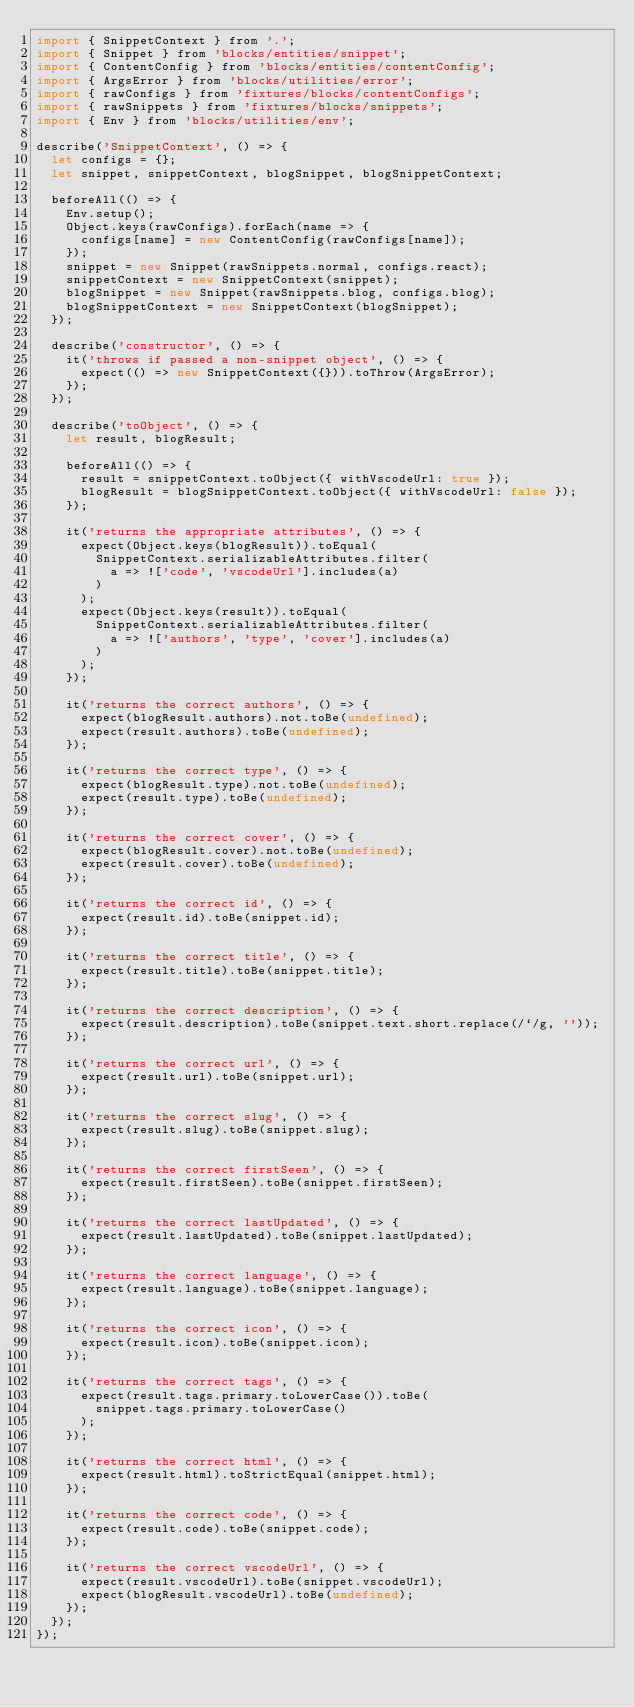Convert code to text. <code><loc_0><loc_0><loc_500><loc_500><_JavaScript_>import { SnippetContext } from '.';
import { Snippet } from 'blocks/entities/snippet';
import { ContentConfig } from 'blocks/entities/contentConfig';
import { ArgsError } from 'blocks/utilities/error';
import { rawConfigs } from 'fixtures/blocks/contentConfigs';
import { rawSnippets } from 'fixtures/blocks/snippets';
import { Env } from 'blocks/utilities/env';

describe('SnippetContext', () => {
  let configs = {};
  let snippet, snippetContext, blogSnippet, blogSnippetContext;

  beforeAll(() => {
    Env.setup();
    Object.keys(rawConfigs).forEach(name => {
      configs[name] = new ContentConfig(rawConfigs[name]);
    });
    snippet = new Snippet(rawSnippets.normal, configs.react);
    snippetContext = new SnippetContext(snippet);
    blogSnippet = new Snippet(rawSnippets.blog, configs.blog);
    blogSnippetContext = new SnippetContext(blogSnippet);
  });

  describe('constructor', () => {
    it('throws if passed a non-snippet object', () => {
      expect(() => new SnippetContext({})).toThrow(ArgsError);
    });
  });

  describe('toObject', () => {
    let result, blogResult;

    beforeAll(() => {
      result = snippetContext.toObject({ withVscodeUrl: true });
      blogResult = blogSnippetContext.toObject({ withVscodeUrl: false });
    });

    it('returns the appropriate attributes', () => {
      expect(Object.keys(blogResult)).toEqual(
        SnippetContext.serializableAttributes.filter(
          a => !['code', 'vscodeUrl'].includes(a)
        )
      );
      expect(Object.keys(result)).toEqual(
        SnippetContext.serializableAttributes.filter(
          a => !['authors', 'type', 'cover'].includes(a)
        )
      );
    });

    it('returns the correct authors', () => {
      expect(blogResult.authors).not.toBe(undefined);
      expect(result.authors).toBe(undefined);
    });

    it('returns the correct type', () => {
      expect(blogResult.type).not.toBe(undefined);
      expect(result.type).toBe(undefined);
    });

    it('returns the correct cover', () => {
      expect(blogResult.cover).not.toBe(undefined);
      expect(result.cover).toBe(undefined);
    });

    it('returns the correct id', () => {
      expect(result.id).toBe(snippet.id);
    });

    it('returns the correct title', () => {
      expect(result.title).toBe(snippet.title);
    });

    it('returns the correct description', () => {
      expect(result.description).toBe(snippet.text.short.replace(/`/g, ''));
    });

    it('returns the correct url', () => {
      expect(result.url).toBe(snippet.url);
    });

    it('returns the correct slug', () => {
      expect(result.slug).toBe(snippet.slug);
    });

    it('returns the correct firstSeen', () => {
      expect(result.firstSeen).toBe(snippet.firstSeen);
    });

    it('returns the correct lastUpdated', () => {
      expect(result.lastUpdated).toBe(snippet.lastUpdated);
    });

    it('returns the correct language', () => {
      expect(result.language).toBe(snippet.language);
    });

    it('returns the correct icon', () => {
      expect(result.icon).toBe(snippet.icon);
    });

    it('returns the correct tags', () => {
      expect(result.tags.primary.toLowerCase()).toBe(
        snippet.tags.primary.toLowerCase()
      );
    });

    it('returns the correct html', () => {
      expect(result.html).toStrictEqual(snippet.html);
    });

    it('returns the correct code', () => {
      expect(result.code).toBe(snippet.code);
    });

    it('returns the correct vscodeUrl', () => {
      expect(result.vscodeUrl).toBe(snippet.vscodeUrl);
      expect(blogResult.vscodeUrl).toBe(undefined);
    });
  });
});
</code> 